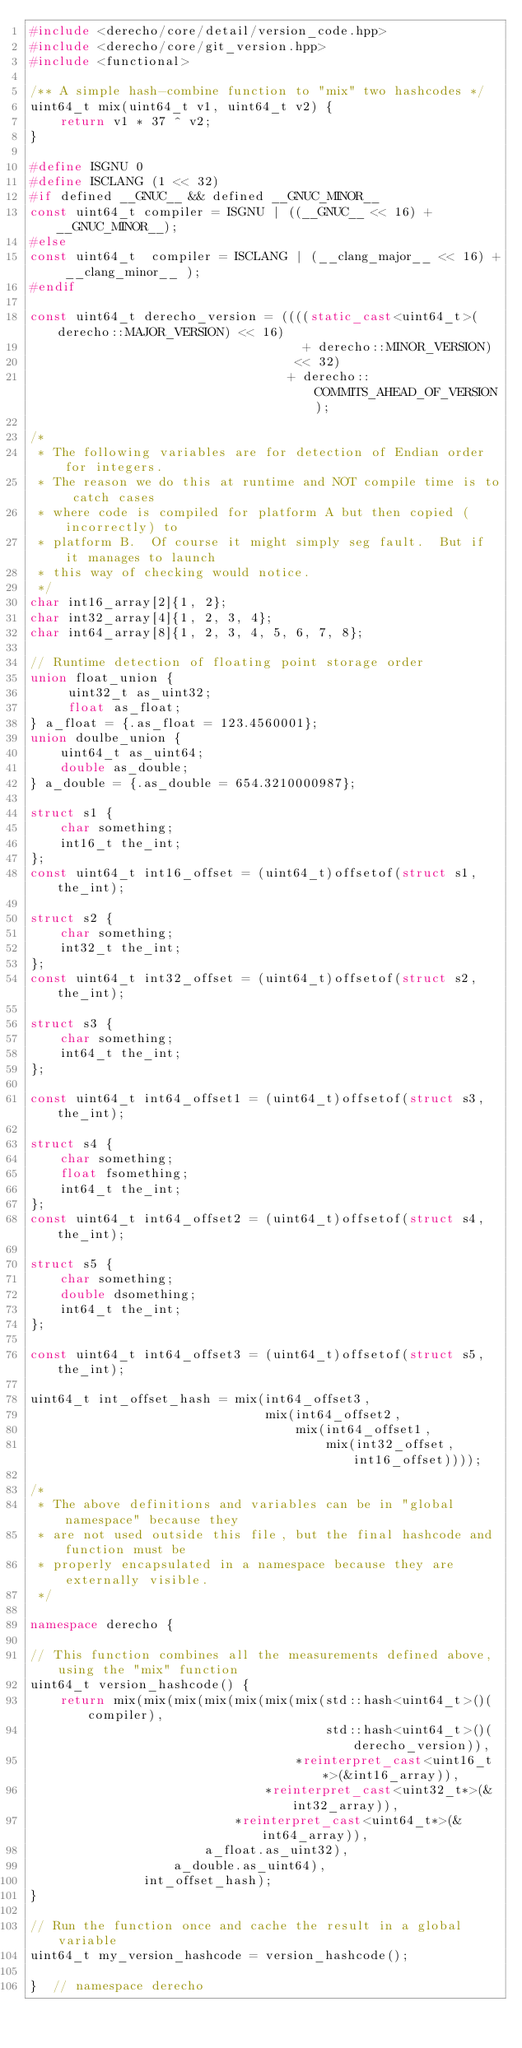<code> <loc_0><loc_0><loc_500><loc_500><_C++_>#include <derecho/core/detail/version_code.hpp>
#include <derecho/core/git_version.hpp>
#include <functional>

/** A simple hash-combine function to "mix" two hashcodes */
uint64_t mix(uint64_t v1, uint64_t v2) {
    return v1 * 37 ^ v2;
}

#define ISGNU 0
#define ISCLANG (1 << 32)
#if defined __GNUC__ && defined __GNUC_MINOR__
const uint64_t compiler = ISGNU | ((__GNUC__ << 16) + __GNUC_MINOR__);
#else
const uint64_t  compiler = ISCLANG | (__clang_major__ << 16) + __clang_minor__ );
#endif

const uint64_t derecho_version = ((((static_cast<uint64_t>(derecho::MAJOR_VERSION) << 16)
                                    + derecho::MINOR_VERSION)
                                   << 32)
                                  + derecho::COMMITS_AHEAD_OF_VERSION);

/*
 * The following variables are for detection of Endian order for integers.
 * The reason we do this at runtime and NOT compile time is to catch cases
 * where code is compiled for platform A but then copied (incorrectly) to
 * platform B.  Of course it might simply seg fault.  But if it manages to launch
 * this way of checking would notice.
 */
char int16_array[2]{1, 2};
char int32_array[4]{1, 2, 3, 4};
char int64_array[8]{1, 2, 3, 4, 5, 6, 7, 8};

// Runtime detection of floating point storage order
union float_union {
     uint32_t as_uint32;
     float as_float;
} a_float = {.as_float = 123.4560001};
union doulbe_union {
    uint64_t as_uint64;
    double as_double;
} a_double = {.as_double = 654.3210000987};

struct s1 {
    char something;
    int16_t the_int;
};
const uint64_t int16_offset = (uint64_t)offsetof(struct s1, the_int);

struct s2 {
    char something;
    int32_t the_int;
};
const uint64_t int32_offset = (uint64_t)offsetof(struct s2, the_int);

struct s3 {
    char something;
    int64_t the_int;
};

const uint64_t int64_offset1 = (uint64_t)offsetof(struct s3, the_int);

struct s4 {
    char something;
    float fsomething;
    int64_t the_int;
};
const uint64_t int64_offset2 = (uint64_t)offsetof(struct s4, the_int);

struct s5 {
    char something;
    double dsomething;
    int64_t the_int;
};

const uint64_t int64_offset3 = (uint64_t)offsetof(struct s5, the_int);

uint64_t int_offset_hash = mix(int64_offset3,
                               mix(int64_offset2,
                                   mix(int64_offset1,
                                       mix(int32_offset, int16_offset))));

/*
 * The above definitions and variables can be in "global namespace" because they
 * are not used outside this file, but the final hashcode and function must be
 * properly encapsulated in a namespace because they are externally visible.
 */

namespace derecho {

// This function combines all the measurements defined above, using the "mix" function
uint64_t version_hashcode() {
    return mix(mix(mix(mix(mix(mix(mix(std::hash<uint64_t>()(compiler),
                                       std::hash<uint64_t>()(derecho_version)),
                                   *reinterpret_cast<uint16_t*>(&int16_array)),
                               *reinterpret_cast<uint32_t*>(&int32_array)),
                           *reinterpret_cast<uint64_t*>(&int64_array)),
                       a_float.as_uint32),
                   a_double.as_uint64),
               int_offset_hash);
}

// Run the function once and cache the result in a global variable
uint64_t my_version_hashcode = version_hashcode();

}  // namespace derecho
</code> 